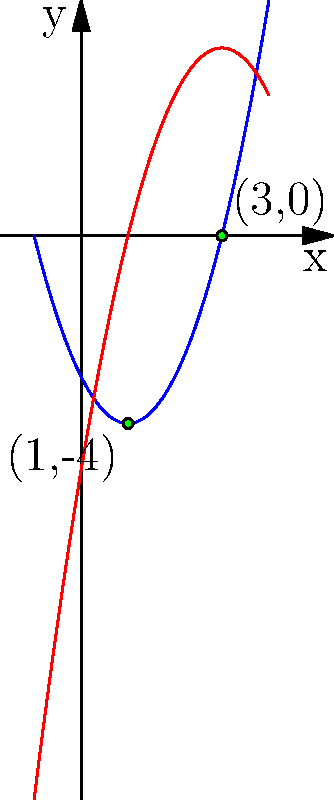As an aspiring journalist covering a local math competition, you've been asked to verify the solution to a challenging problem. The problem involves finding the points of intersection between two polynomial functions: $f(x) = x^2 - 2x - 3$ and $g(x) = -x^2 + 6x - 5$. Can you determine the coordinates of these intersection points? To find the points of intersection, we need to solve the equation $f(x) = g(x)$:

1) Set up the equation:
   $x^2 - 2x - 3 = -x^2 + 6x - 5$

2) Rearrange terms to standard form:
   $2x^2 - 8x + 2 = 0$

3) Divide all terms by 2 to simplify:
   $x^2 - 4x + 1 = 0$

4) This is a quadratic equation. We can solve it using the quadratic formula:
   $x = \frac{-b \pm \sqrt{b^2 - 4ac}}{2a}$
   where $a = 1$, $b = -4$, and $c = 1$

5) Plugging in the values:
   $x = \frac{4 \pm \sqrt{16 - 4}}{2} = \frac{4 \pm \sqrt{12}}{2} = \frac{4 \pm 2\sqrt{3}}{2}$

6) Simplify:
   $x = 2 \pm \sqrt{3}$

7) So, the x-coordinates of the intersection points are:
   $x_1 = 2 + \sqrt{3}$ and $x_2 = 2 - \sqrt{3}$

8) To find the y-coordinates, we can substitute these x-values into either $f(x)$ or $g(x)$. Let's use $f(x)$:

   For $x_1 = 2 + \sqrt{3}$:
   $f(2 + \sqrt{3}) = (2 + \sqrt{3})^2 - 2(2 + \sqrt{3}) - 3 = 7 + 4\sqrt{3} - 4 - 2\sqrt{3} - 3 = 0$

   For $x_2 = 2 - \sqrt{3}$:
   $f(2 - \sqrt{3}) = (2 - \sqrt{3})^2 - 2(2 - \sqrt{3}) - 3 = 7 - 4\sqrt{3} - 4 + 2\sqrt{3} - 3 = 0$

Therefore, the points of intersection are $(2 + \sqrt{3}, 0)$ and $(2 - \sqrt{3}, 0)$.
Answer: $(2 + \sqrt{3}, 0)$ and $(2 - \sqrt{3}, 0)$ 